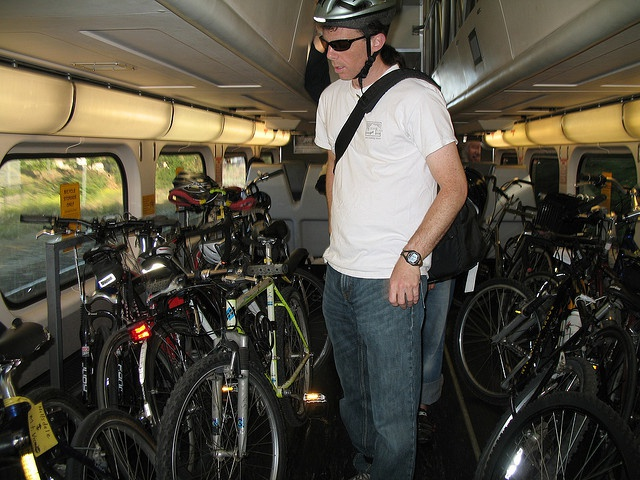Describe the objects in this image and their specific colors. I can see people in gray, lightgray, black, and purple tones, bicycle in gray, black, darkgray, and darkgreen tones, bicycle in gray, black, white, and darkgray tones, bicycle in gray, black, and darkgray tones, and bicycle in gray, black, and olive tones in this image. 